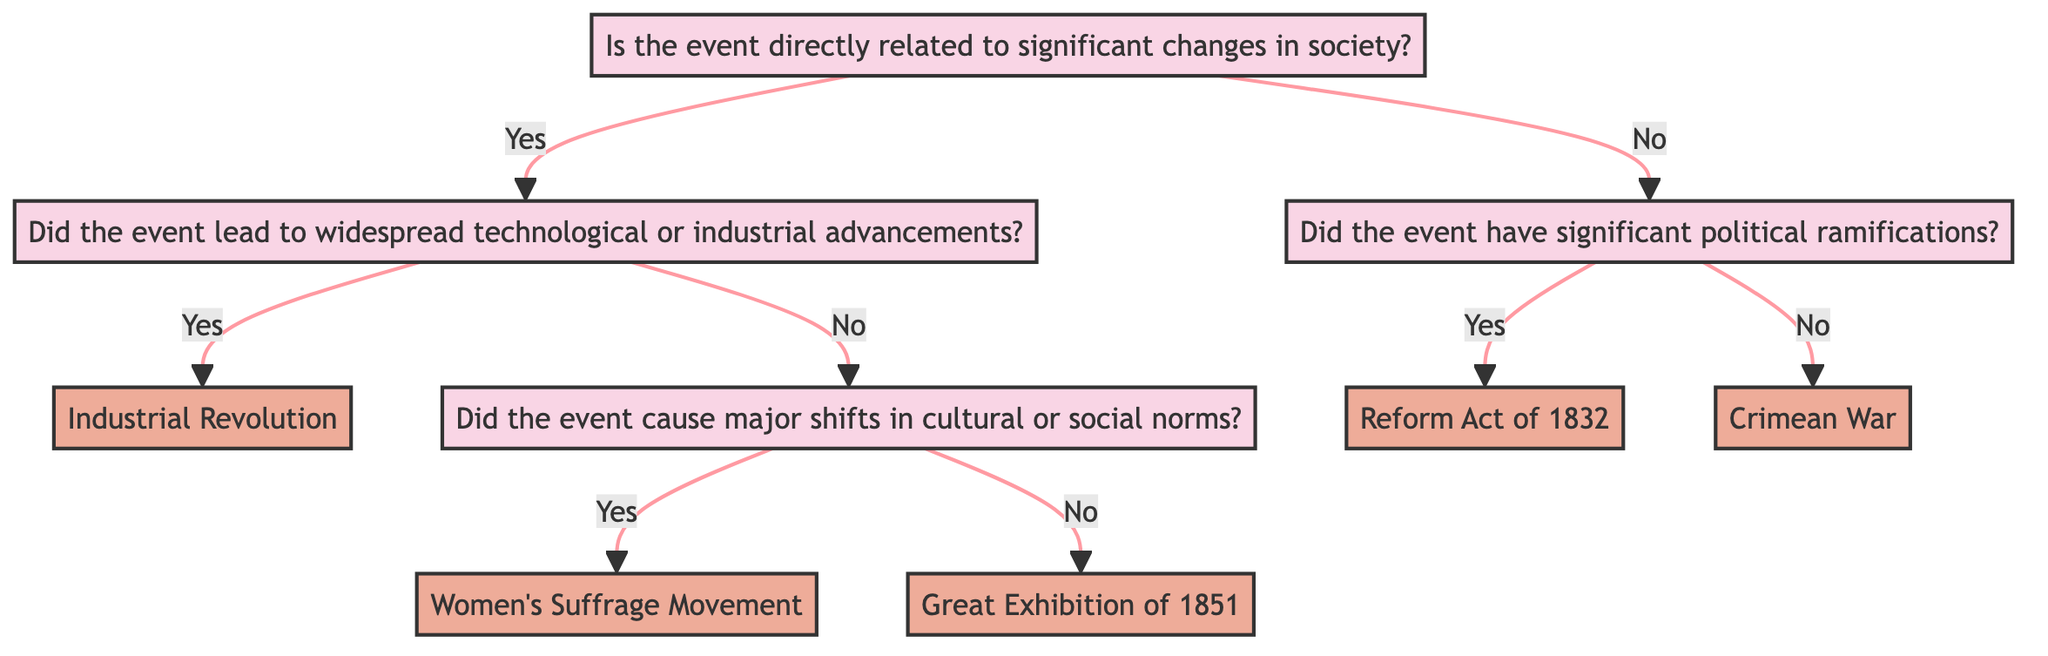Is the first question about the diagram related to society? The first question at the top of the decision tree asks if the event is directly related to significant changes in society. Since it is the starting point of the diagram, its focus is on societal impacts.
Answer: Yes How many main branches are there in the diagram? The diagram starts with one initial question that splits into two main branches ("Yes" and "No"). Each of these branches further divides, but the two main options are what defines the branching structure.
Answer: 2 What event is identified if the answer is 'Yes' to technological advancements? If the answer to the second question (whether it leads to widespread technological or industrial advancements) is 'Yes', it leads us directly to the event identified as the "Industrial Revolution".
Answer: Industrial Revolution What question follows if the answer is 'No' to major technological advancements? The follow-up question after answering 'No' to the technological advancements is about whether the event caused major shifts in cultural or social norms. This question evaluates the cultural impacts subsequent to the technological inquiry.
Answer: Did the event cause major shifts in cultural or social norms? What political event is mentioned in the diagram? The political event mentioned in the diagram occurs after answering 'Yes' to the question regarding significant political ramifications, leading to the "Reform Act of 1832".
Answer: Reform Act of 1832 If the answer to the societal impact question is 'No', what event is referenced? If the answer is 'No' to the societal impact question and 'No' to the question on political ramifications, it ends with the event "Crimean War". This relationship shows how the decision paths lead to specific events based on responses.
Answer: Crimean War How many events are described in the diagram? Counting the events listed under each path in the decision tree, we have four distinct events: "Industrial Revolution," "Women's Suffrage Movement," "Great Exhibition of 1851," and "Reform Act of 1832," and "Crimean War." Thus, there are five events total.
Answer: 5 What is the outcome if the event has significant political ramifications? The decision leads us to acknowledge the outcome described as the "Reform Act of 1832". This is the result of following the path based on the political significance of the event.
Answer: Reform Act of 1832 